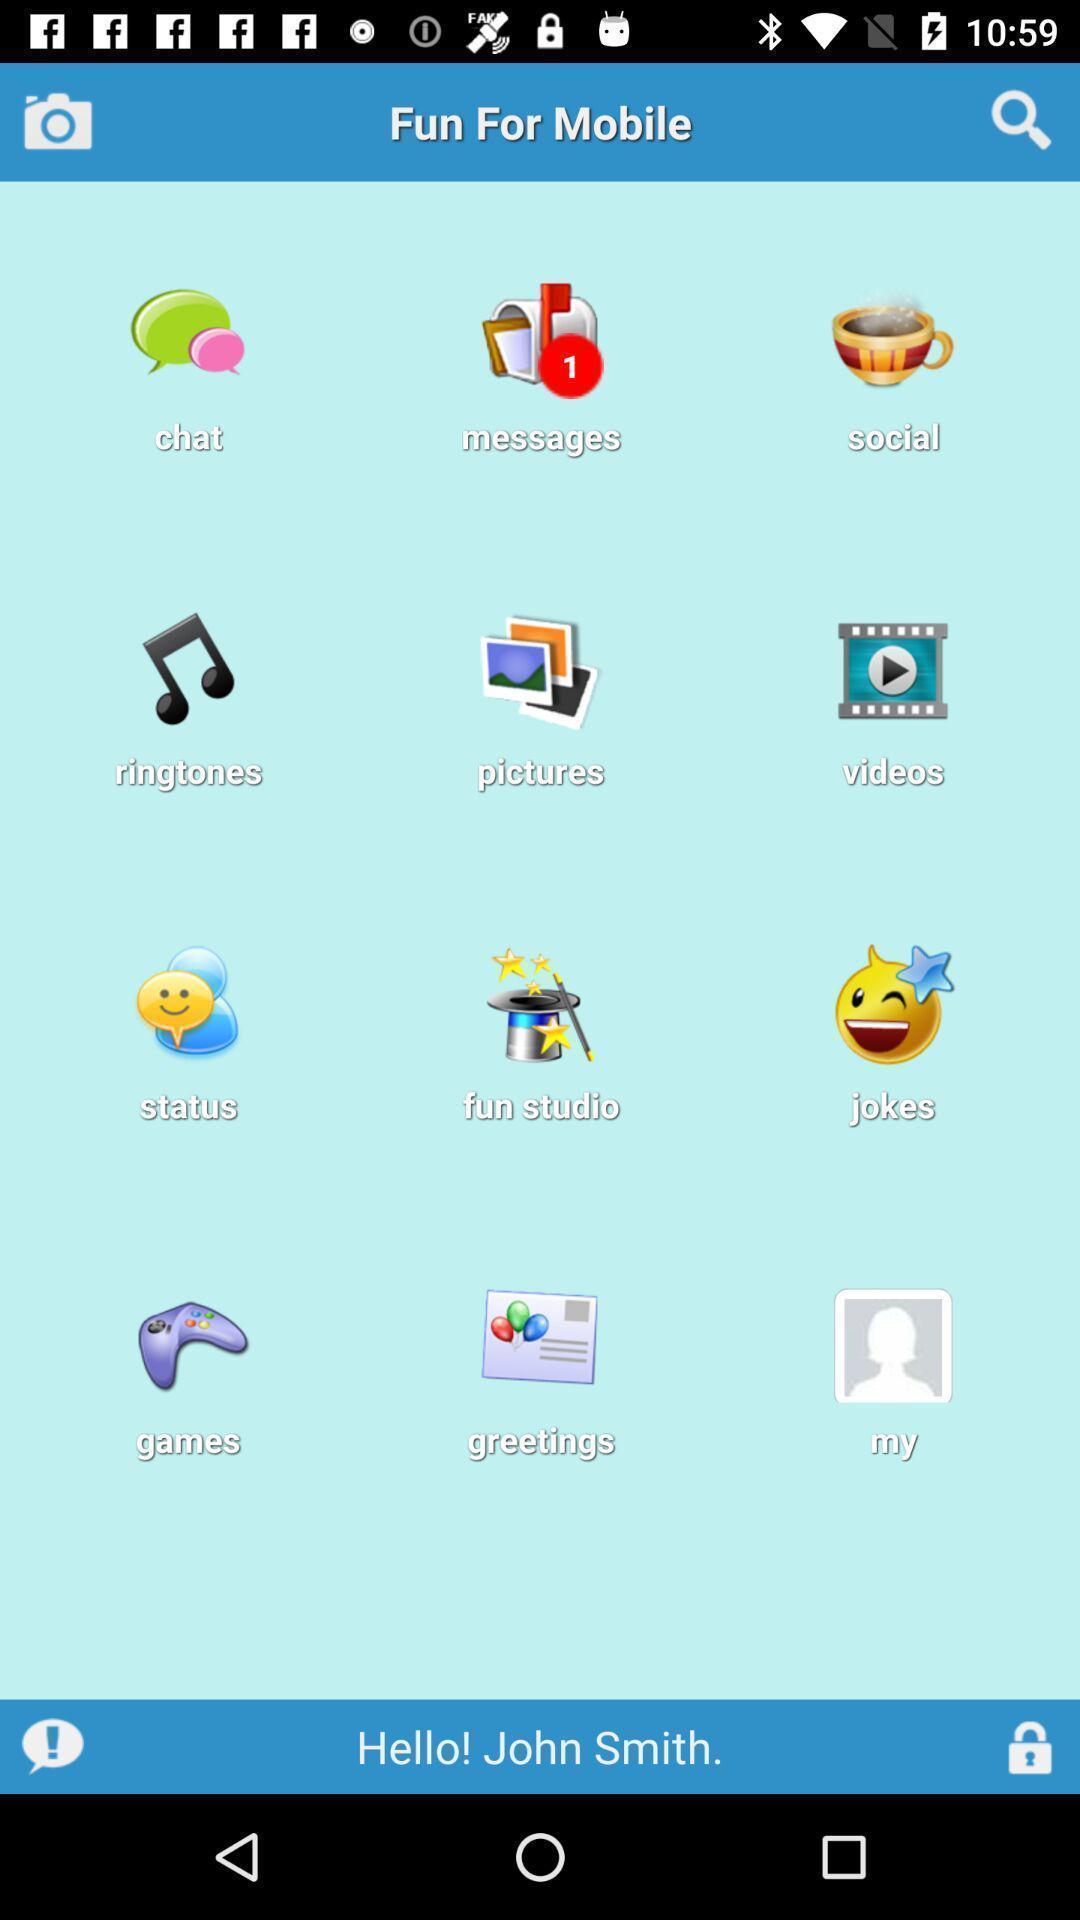Explain the elements present in this screenshot. Page displaying list of app icons. 